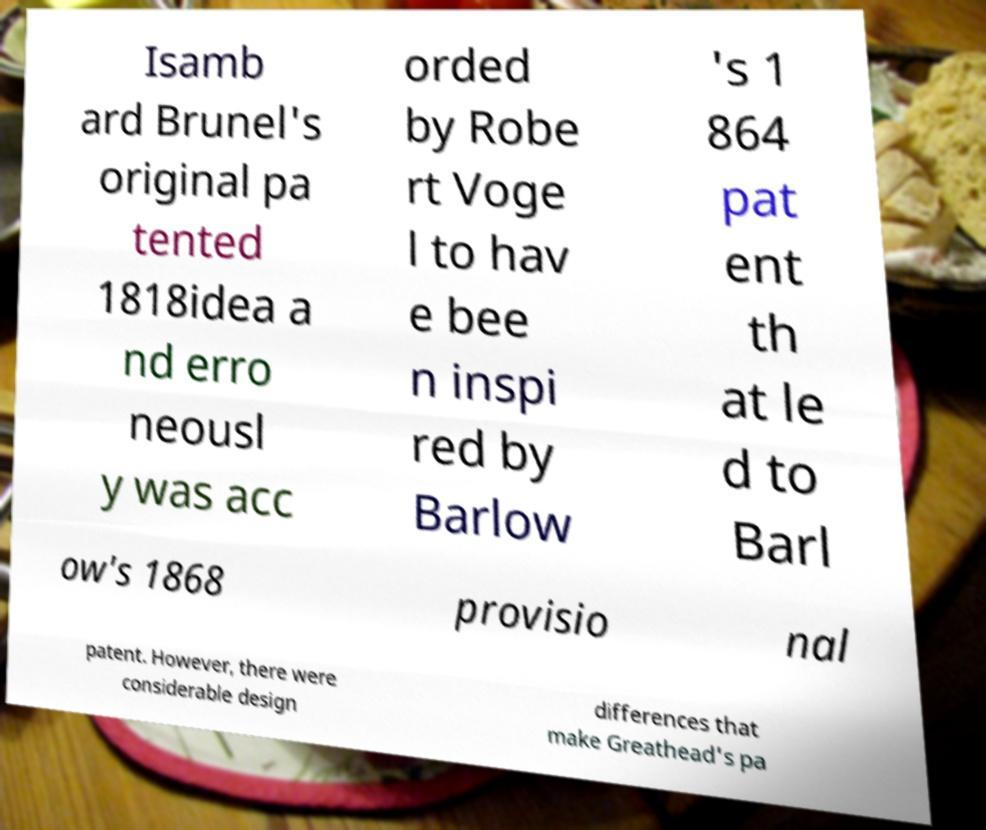Can you accurately transcribe the text from the provided image for me? Isamb ard Brunel's original pa tented 1818idea a nd erro neousl y was acc orded by Robe rt Voge l to hav e bee n inspi red by Barlow 's 1 864 pat ent th at le d to Barl ow's 1868 provisio nal patent. However, there were considerable design differences that make Greathead's pa 